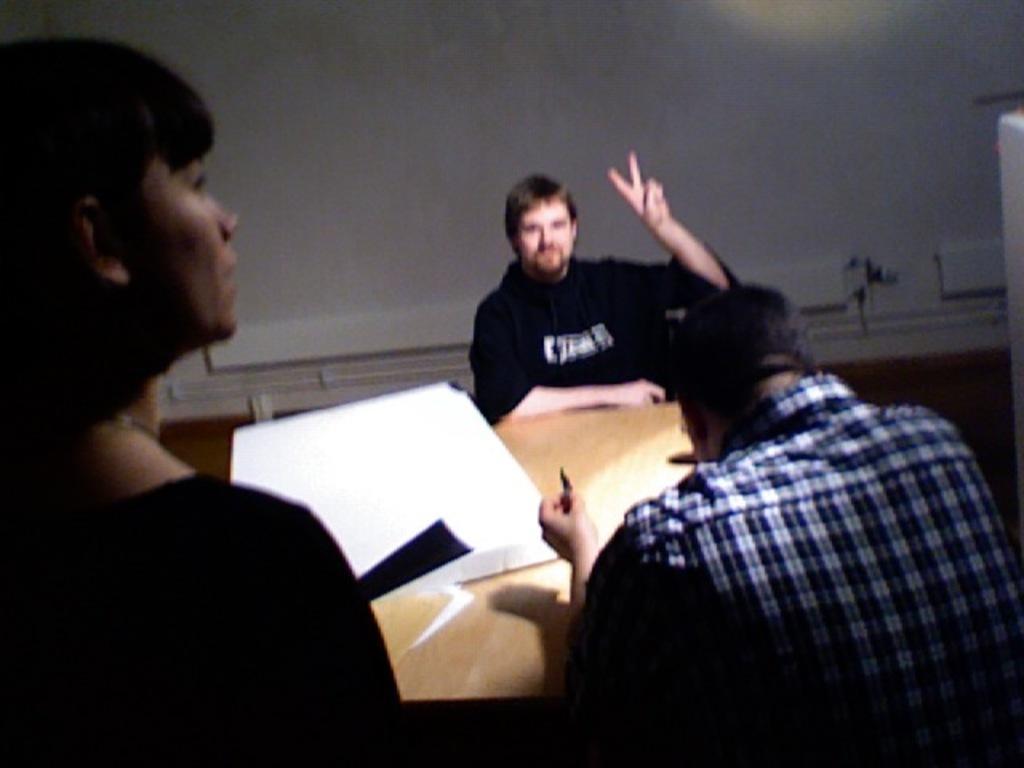How would you summarize this image in a sentence or two? This picture shows couple of men seated on the chairs and we see a woman standing. We see a box on the table and we see white color wall on the back. 